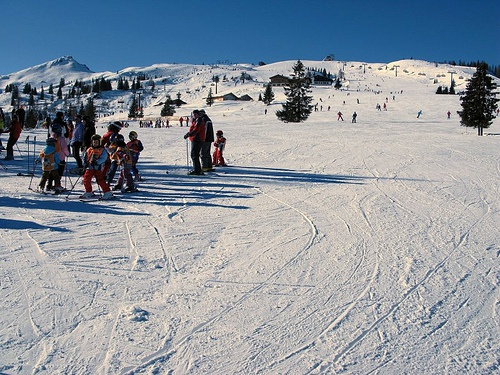Describe the objects in this image and their specific colors. I can see people in blue, black, maroon, and navy tones, people in blue, black, darkblue, maroon, and gray tones, people in blue, black, maroon, gray, and darkgray tones, people in blue, black, purple, and maroon tones, and people in blue, black, gray, darkgray, and maroon tones in this image. 